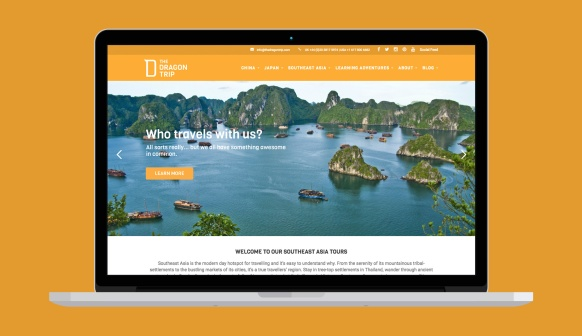Can you describe what kind of adventures one might experience with this company? With Dragon Trip, adventurers can expect a wide array of experiences across the stunning landscapes of Southeast Asia. Imagine trekking through lush, dense jungles, discovering hidden temples, and walking through vibrant markets filled with exotic goods and tantalizing street food. You might find yourself sailing between breathtaking limestone karst islands, snorkeling in crystal-clear waters teeming with marine life, or participating in immersive cultural exchanges with local communities. Whether you prefer adrenaline-pumping activities or serene, reflective moments in nature, Dragon Trip offers an itinerary that caters to every traveler's interests and pace. 